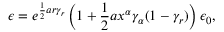<formula> <loc_0><loc_0><loc_500><loc_500>\epsilon = e ^ { \frac { 1 } { 2 } a r \gamma _ { r } } \left ( 1 + \frac { 1 } { 2 } a x ^ { \alpha } \gamma _ { \alpha } ( 1 - \gamma _ { r } ) \right ) \epsilon _ { 0 } ,</formula> 